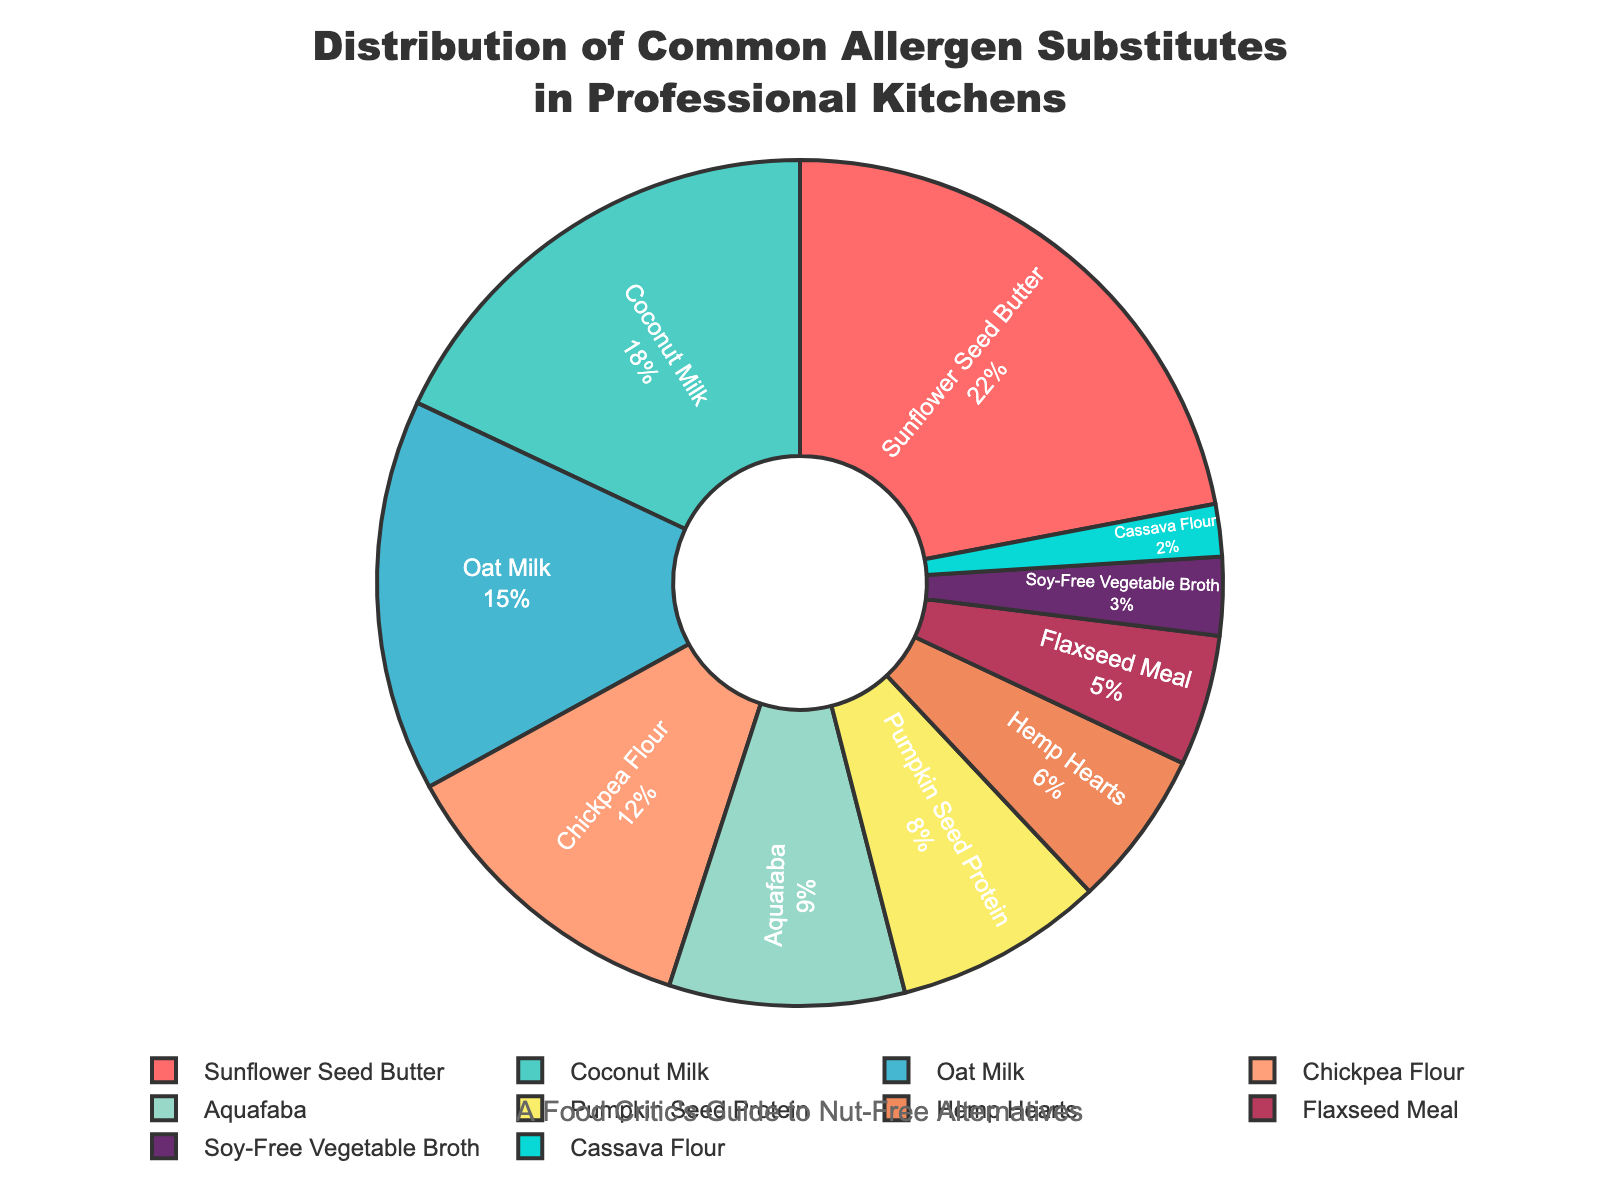What is the most commonly used allergen substitute in the figure? The figure shows a pie chart with different allergen substitutes and their percentages. By identifying the segment with the largest percentage, we see that Sunflower Seed Butter is the largest at 22%.
Answer: Sunflower Seed Butter Which allergen substitute has a lower percentage, Oat Milk or Coconut Milk? The figure lists the percentages for each substitute. Oat Milk has 15%, while Coconut Milk has 18%. Since 15% is less than 18%, Oat Milk has a lower percentage than Coconut Milk.
Answer: Oat Milk How much combined percentage do Sunflower Seed Butter and Aquafaba hold? The percentages for Sunflower Seed Butter and Aquafaba are 22% and 9% respectively. Adding them together gives 22% + 9% = 31%.
Answer: 31% By how much percentage does Pumpkin Seed Protein fall short of Chickpea Flour? The figure shows that Chickpea Flour is at 12% and Pumpkin Seed Protein is at 8%. The difference is 12% - 8% = 4%.
Answer: 4% What is the total percentage of allergen substitutes that have a percentage less than 10%? The substitutes with percentages less than 10% are Aquafaba (9%), Pumpkin Seed Protein (8%), Hemp Hearts (6%), Flaxseed Meal (5%), Soy-Free Vegetable Broth (3%), and Cassava Flour (2%). Adding these together gives 9% + 8% + 6% + 5% + 3% + 2% = 33%.
Answer: 33% How much larger is the segment for Oat Milk compared to Hemp Hearts in terms of percentage? The figure shows Oat Milk at 15% and Hemp Hearts at 6%. The difference is 15% - 6% = 9%.
Answer: 9% What color is associated with Aquafaba in the pie chart? Examining the figure, the segment for Aquafaba is colored in a distinct hue. This is the color marker assigned to this specific allergen substitute.
Answer: #F08A5D (orange-like hue) How does the percentage of Flaxseed Meal compare to Soy-Free Vegetable Broth? The figure shows Flaxseed Meal at 5% and Soy-Free Vegetable Broth at 3%. Since 5% is greater than 3%, Flaxseed Meal has a higher percentage.
Answer: Flaxseed Meal Among the allergen substitutes shown, which two have the smallest percentages and what are they? According to the figure, Soy-Free Vegetable Broth and Cassava Flour have the smallest percentages at 3% and 2% respectively.
Answer: Soy-Free Vegetable Broth and Cassava Flour 